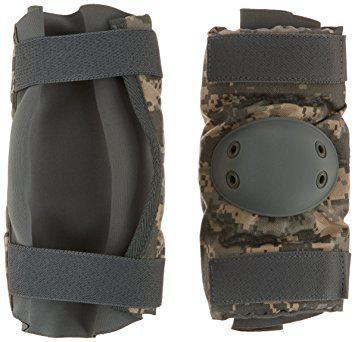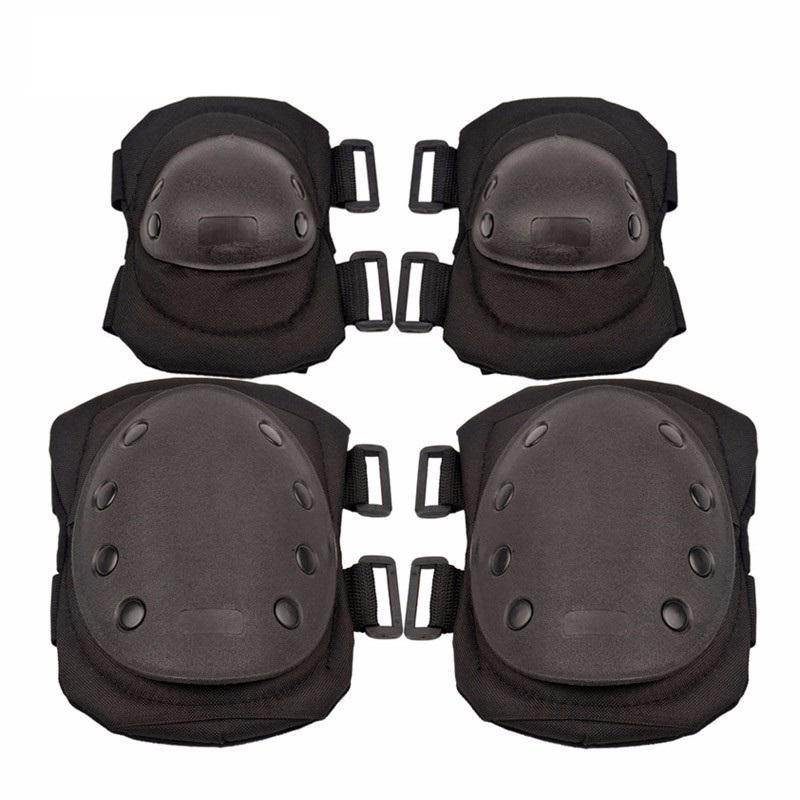The first image is the image on the left, the second image is the image on the right. For the images shown, is this caption "The combined images contain eight protective pads." true? Answer yes or no. No. The first image is the image on the left, the second image is the image on the right. Analyze the images presented: Is the assertion "There are more pads in the image on the left than in the image on the right." valid? Answer yes or no. No. 